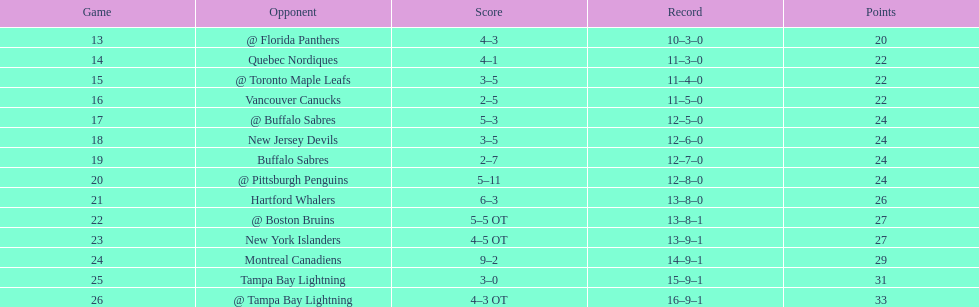What was the total penalty minutes that dave brown had on the 1993-1994 flyers? 137. 